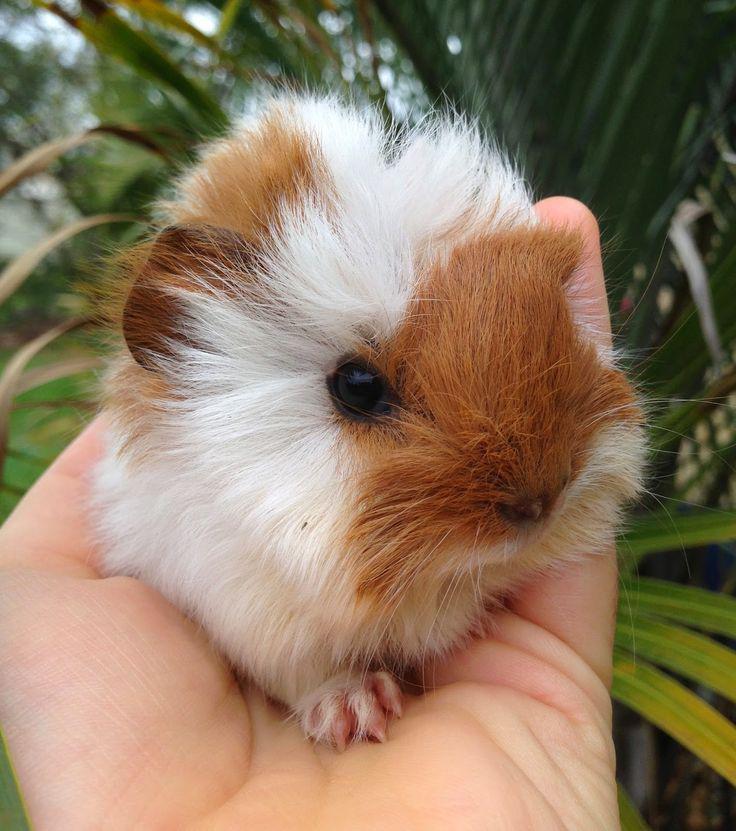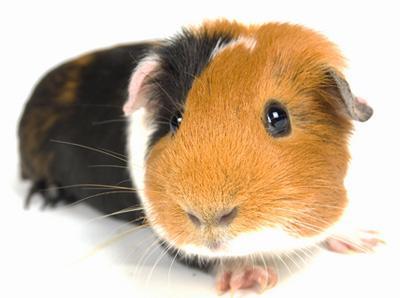The first image is the image on the left, the second image is the image on the right. Considering the images on both sides, is "There are two guinea pigs in one image." valid? Answer yes or no. No. The first image is the image on the left, the second image is the image on the right. Given the left and right images, does the statement "There are at least four guinea pigs in total." hold true? Answer yes or no. No. 